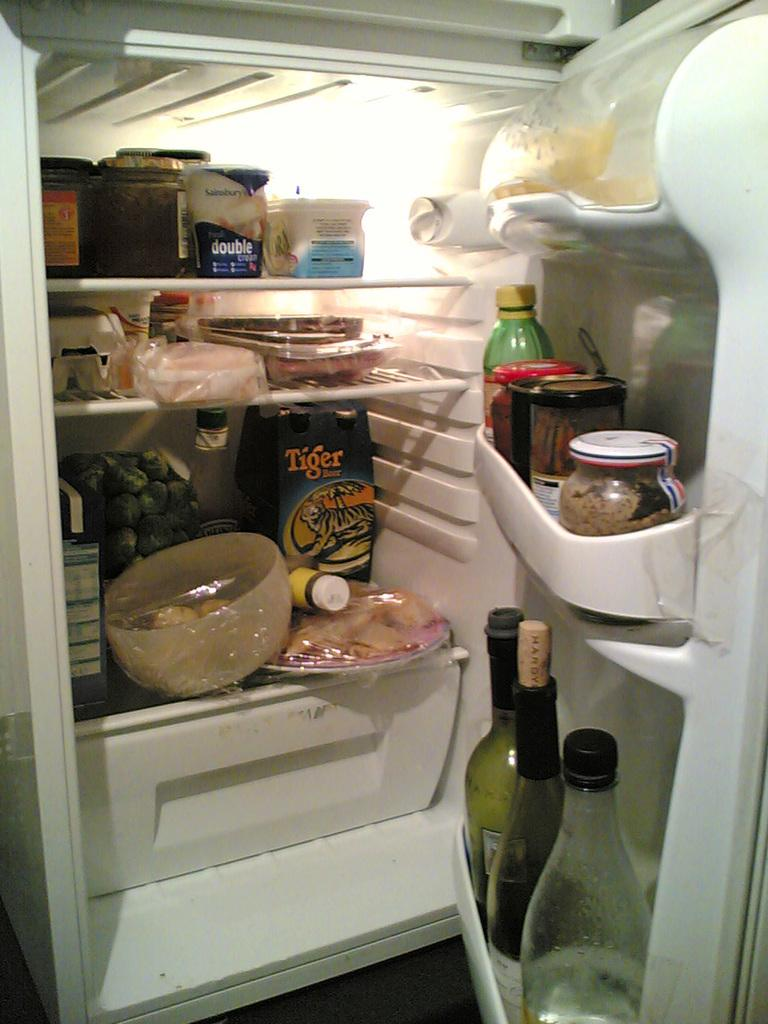<image>
Share a concise interpretation of the image provided. an open refrigerator with a 6 pack of tiger beer 